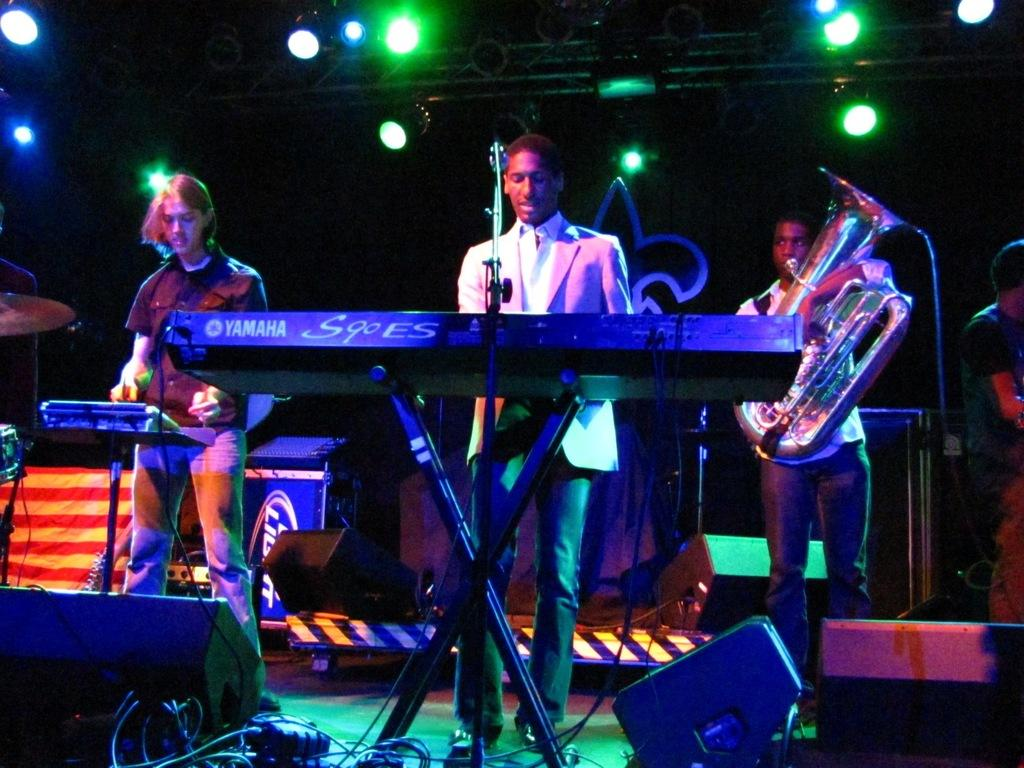What can be seen in the image involving people? There are people standing in the image. What are the people wearing? The people are wearing clothes. What other objects are present in the image related to music or performance? There are musical instruments, a microphone, cable wires, a light, and a podium in the image. How does the face of the person on the left increase the volume of the band in the image? There is no face or band present in the image; it only shows people, musical instruments, and other performance-related objects. 